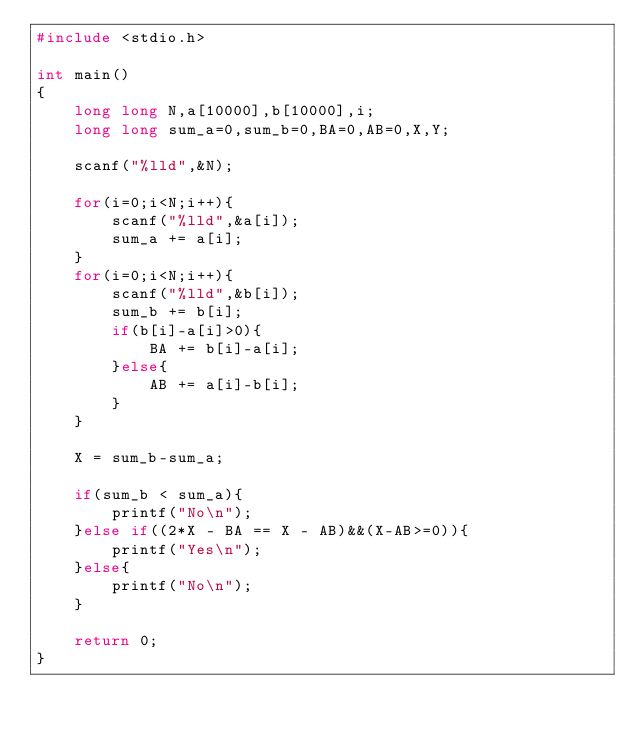Convert code to text. <code><loc_0><loc_0><loc_500><loc_500><_C_>#include <stdio.h>

int main()
{
    long long N,a[10000],b[10000],i;
    long long sum_a=0,sum_b=0,BA=0,AB=0,X,Y;

    scanf("%lld",&N);

    for(i=0;i<N;i++){
        scanf("%lld",&a[i]);
        sum_a += a[i];
    }
    for(i=0;i<N;i++){
        scanf("%lld",&b[i]);
        sum_b += b[i];
        if(b[i]-a[i]>0){
            BA += b[i]-a[i];
        }else{
            AB += a[i]-b[i];
        }
    }

    X = sum_b-sum_a;

    if(sum_b < sum_a){
        printf("No\n");
    }else if((2*X - BA == X - AB)&&(X-AB>=0)){
        printf("Yes\n");
    }else{
        printf("No\n");
    }

    return 0;
}
</code> 